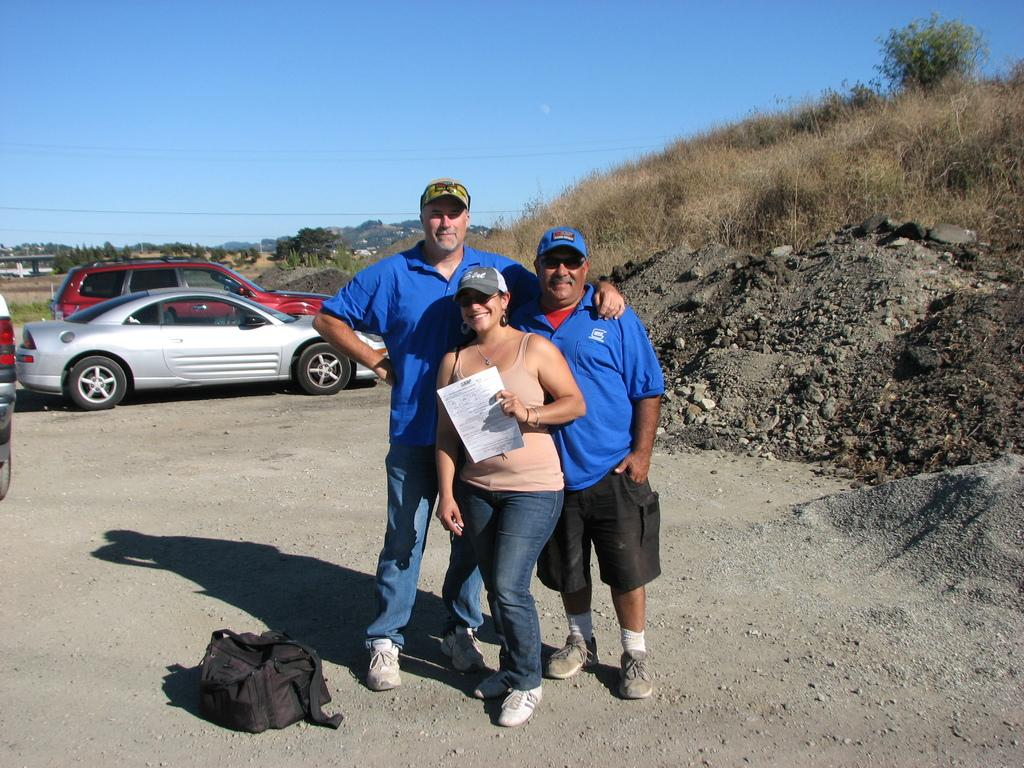What is happening in the center of the image? There are persons standing on the ground in the center of the image. What can be seen in the background of the image? There are cars, trees, a hill, houses, and the sky visible in the background of the image. Where is the sofa located in the image? There is no sofa present in the image. What type of scarecrow can be seen standing on the hill in the image? There is no scarecrow present in the image; the hill has no visible objects or figures. 